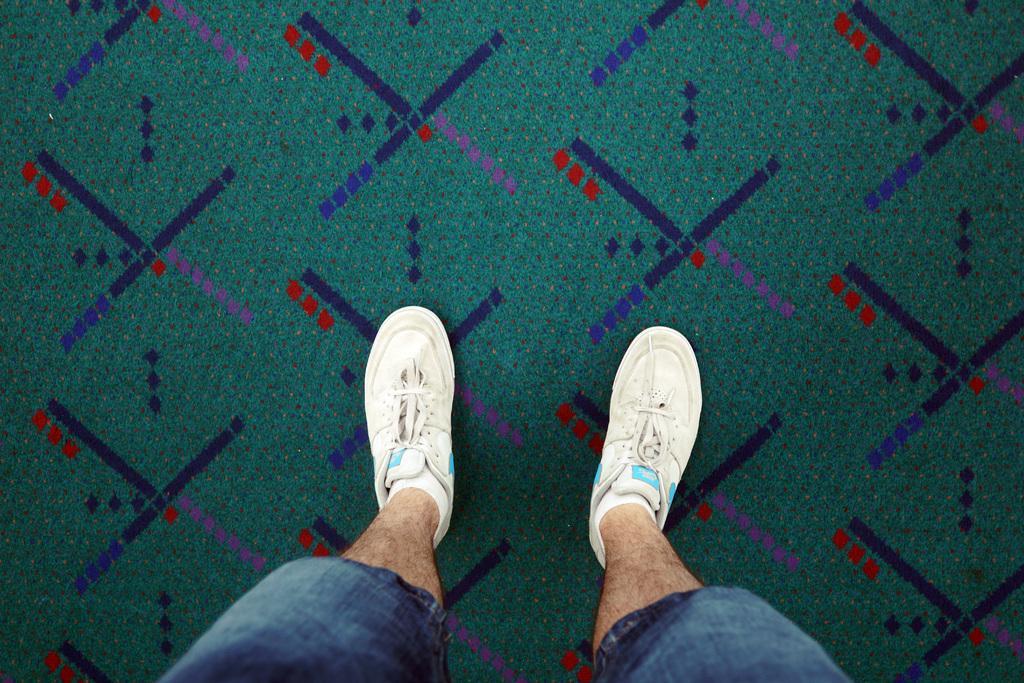Could you give a brief overview of what you see in this image? In the image there is a person standing on a carpet, the person is wearing white shoes and only the legs of the person are visible in the image. 